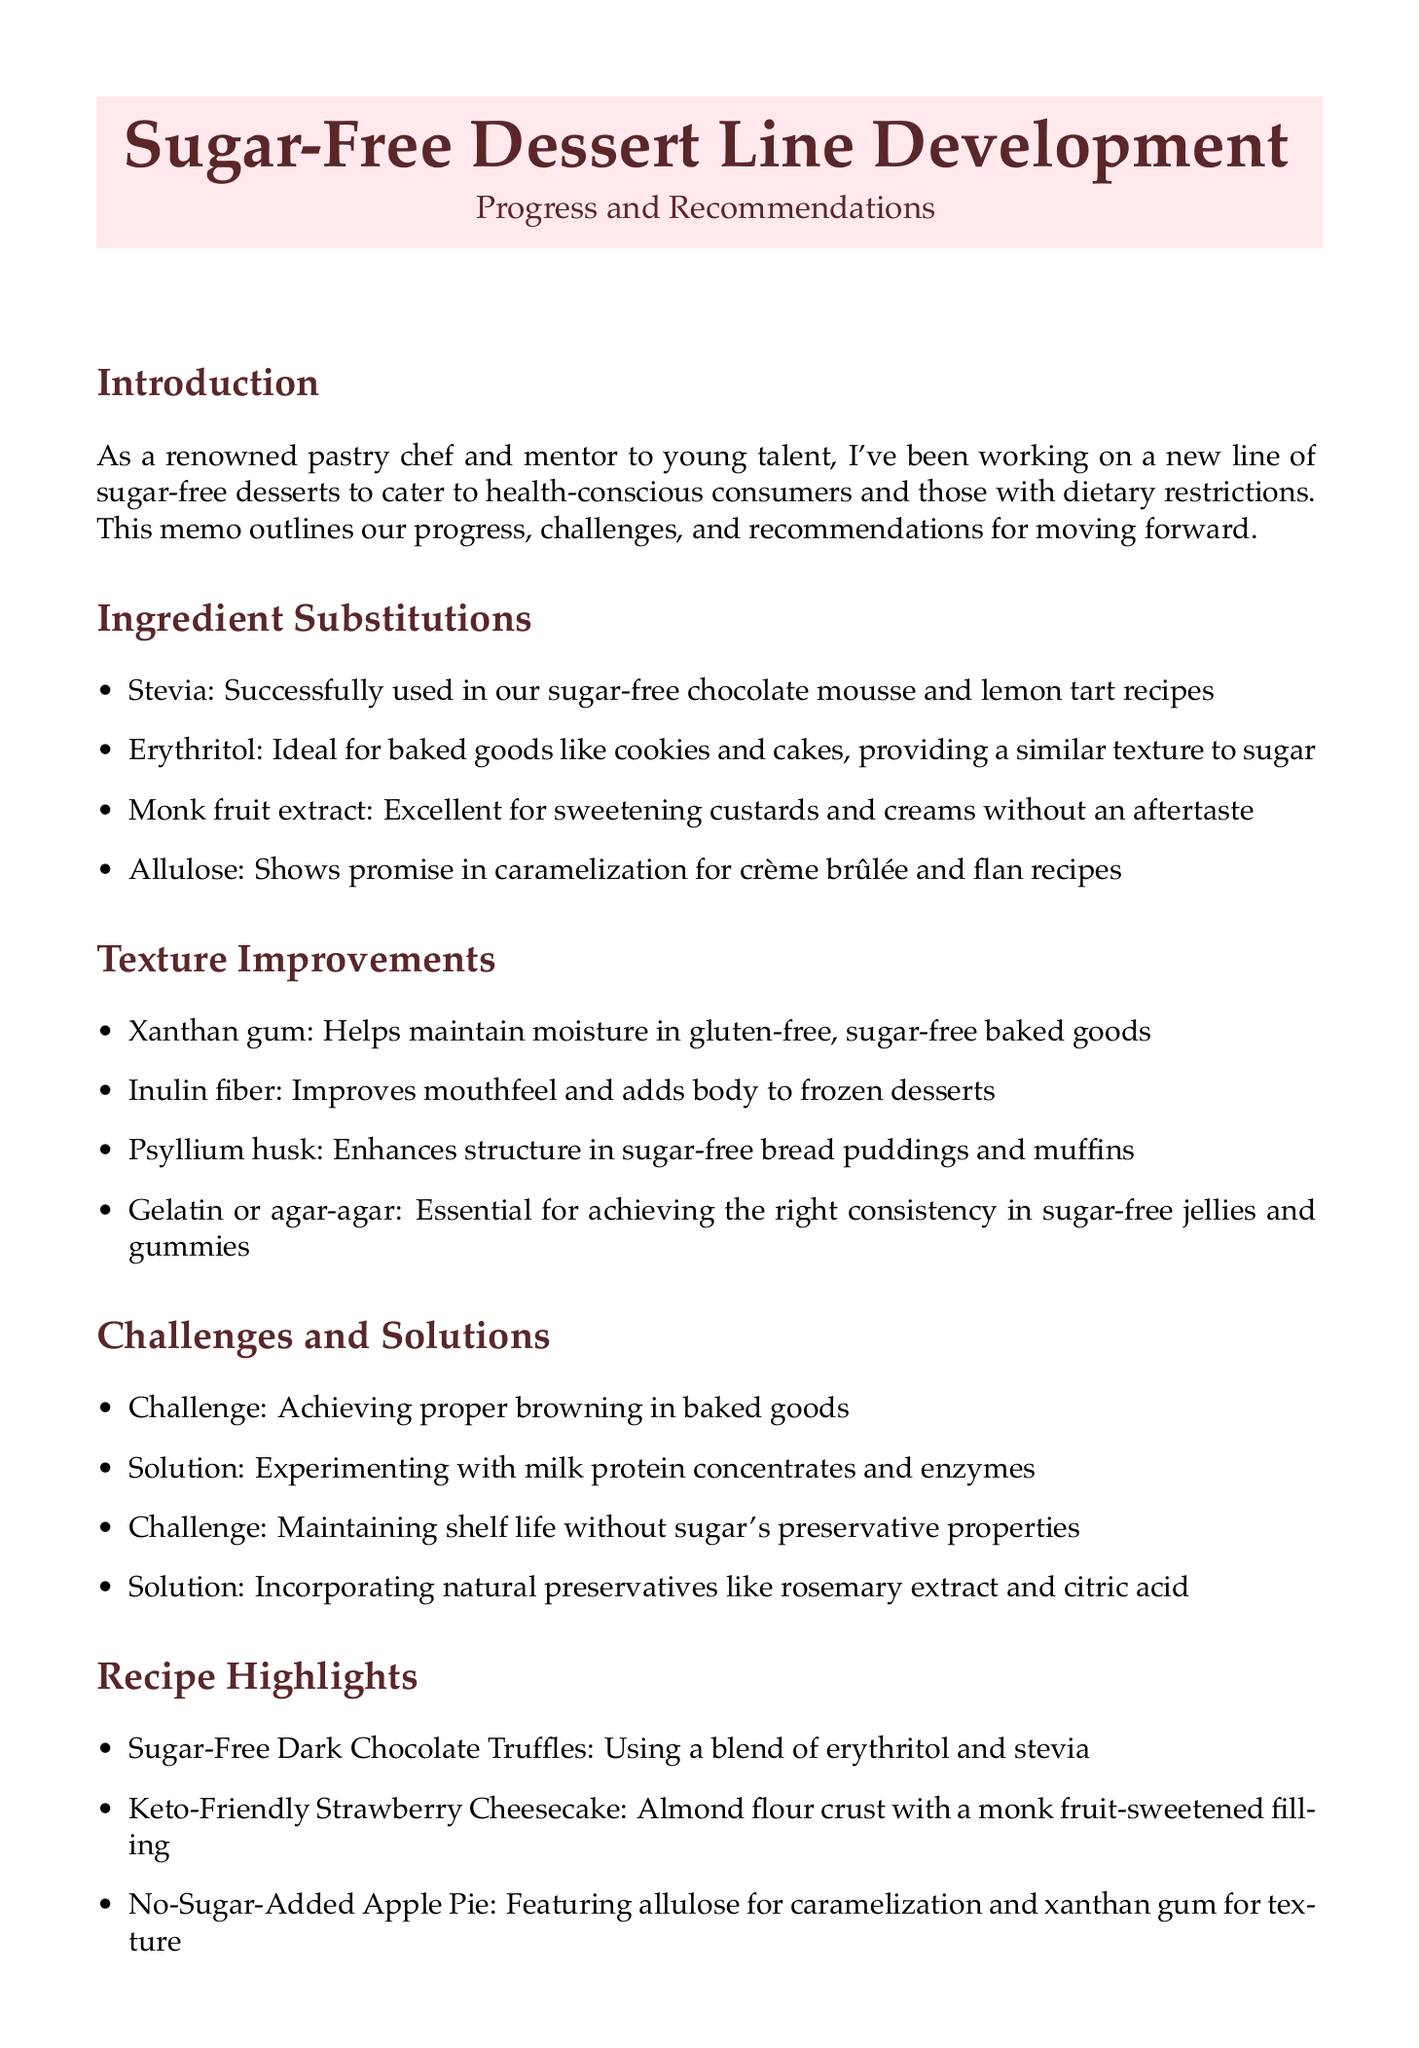What is the title of the memo? The title of the memo is clearly stated at the beginning as "Sugar-Free Dessert Line Development: Progress and Recommendations."
Answer: Sugar-Free Dessert Line Development: Progress and Recommendations Who is working closely with Emma Thompson? Emma Thompson is being mentored by a renowned pastry chef, who is the author of the memo.
Answer: A renowned pastry chef What is one ingredient used in the sugar-free chocolate mousse? The memo details that stevia was successfully used in the sugar-free chocolate mousse recipe.
Answer: Stevia Which ingredient improves mouthfeel in frozen desserts? Inulin fiber is mentioned in the memo as improving mouthfeel and adding body to frozen desserts.
Answer: Inulin fiber What is a challenge mentioned related to baked goods? The memo lists achieving proper browning in baked goods as one of the challenges faced.
Answer: Achieving proper browning What is one of the next steps outlined in the memo? The author notes conducting taste tests with focus groups as a next step in the development process.
Answer: Conduct taste tests with focus groups Which natural preservative is suggested for shelf life? The memo recommends incorporating rosemary extract as a natural preservative.
Answer: Rosemary extract How many recipe highlights are provided in the document? The document has a section providing three recipe highlights for the sugar-free dessert line.
Answer: Three What type of dessert is the No-Sugar-Added Apple Pie? The No-Sugar-Added Apple Pie is highlighted as featuring allulose for caramelization in the memo.
Answer: Allulose for caramelization 